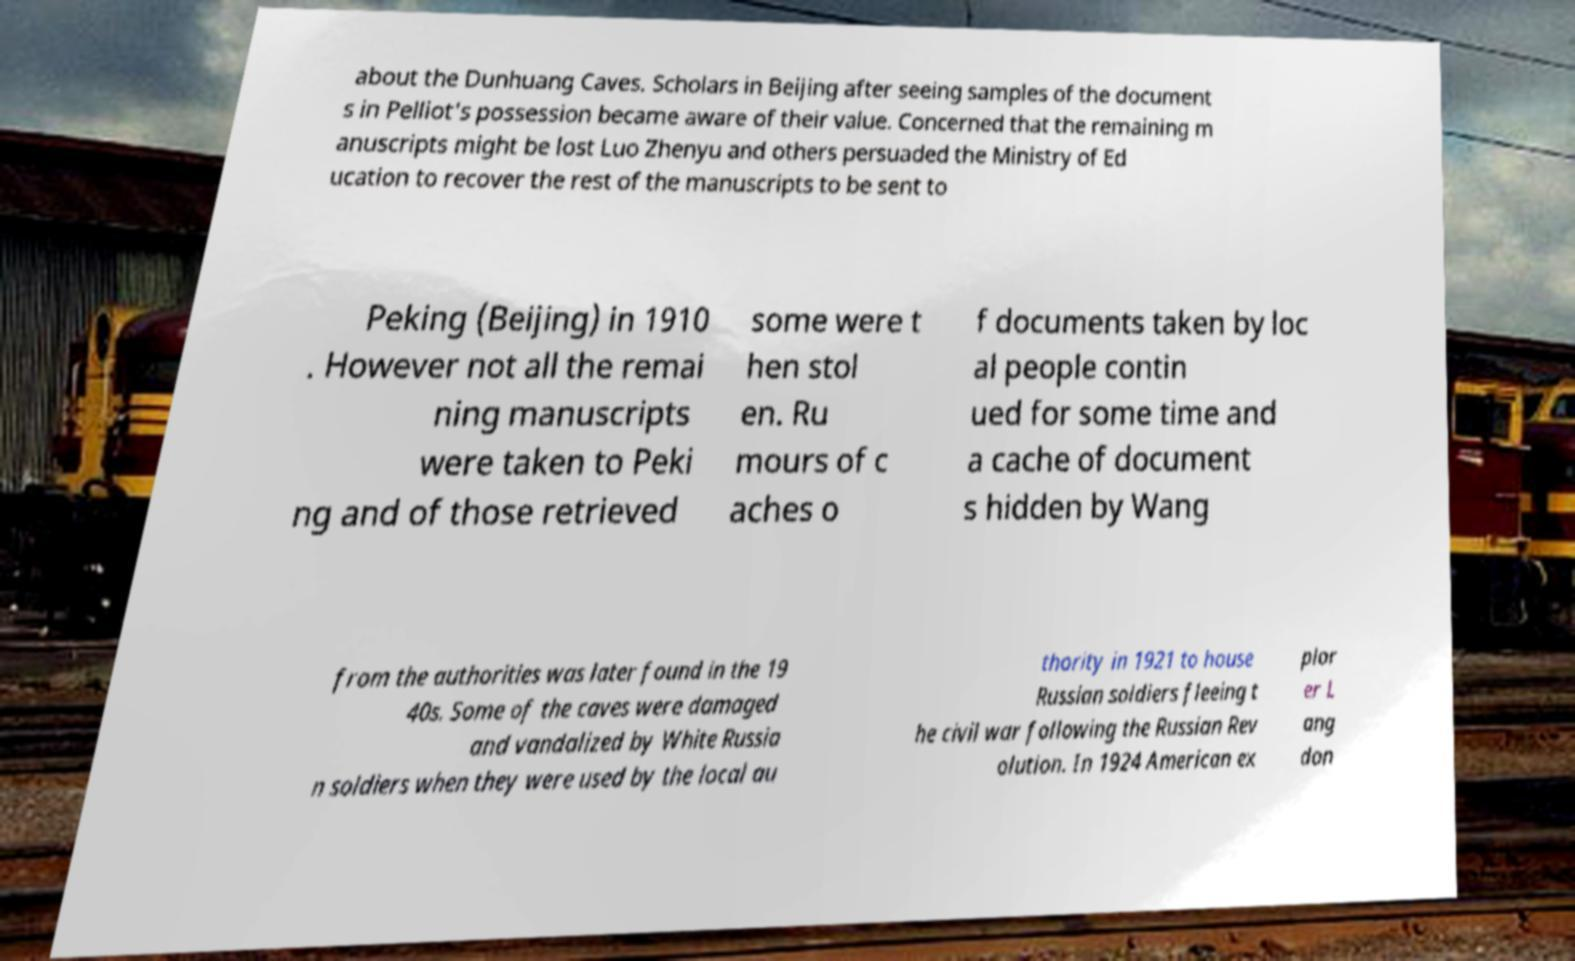There's text embedded in this image that I need extracted. Can you transcribe it verbatim? about the Dunhuang Caves. Scholars in Beijing after seeing samples of the document s in Pelliot's possession became aware of their value. Concerned that the remaining m anuscripts might be lost Luo Zhenyu and others persuaded the Ministry of Ed ucation to recover the rest of the manuscripts to be sent to Peking (Beijing) in 1910 . However not all the remai ning manuscripts were taken to Peki ng and of those retrieved some were t hen stol en. Ru mours of c aches o f documents taken by loc al people contin ued for some time and a cache of document s hidden by Wang from the authorities was later found in the 19 40s. Some of the caves were damaged and vandalized by White Russia n soldiers when they were used by the local au thority in 1921 to house Russian soldiers fleeing t he civil war following the Russian Rev olution. In 1924 American ex plor er L ang don 